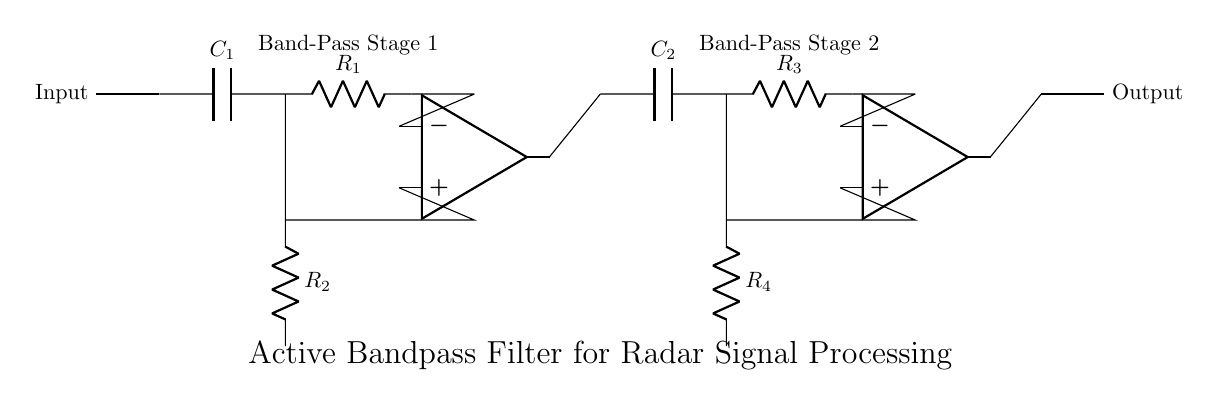What are the two main types of components used in this active bandpass filter? The circuit contains capacitors and resistors. Capacitance is represented by C_1 and C_2, while resistance is depicted by R_1, R_2, R_3, and R_4.
Answer: capacitors and resistors What is the purpose of the operational amplifiers in this circuit? The operational amplifiers (op amps) serve to amplify the signals after they pass through the filtering stages, providing the necessary gain for effective radar signal processing.
Answer: amplify signals How many stages does this active bandpass filter consist of? The diagram shows two band-pass stages, each including its own set of components for filtering.
Answer: two stages What is the configuration of the first stage of this active bandpass filter? The first stage consists of a capacitor (C_1) in series with a resistor (R_1) and a parallel combination of resistor (R_2) to ground. This configuration allows for filtering of specific frequency ranges.
Answer: series and parallel configuration What happens to the input signal as it passes through the filter? The input signal is attenuated for frequencies outside the passband determined by the configuration of the capacitors and resistors. Only desired frequencies will be amplified and sent to the output.
Answer: attenuated and amplified Which component determines the cutoff frequency of the filter? The cutoff frequency is determined by the values of the capacitors and the resistors in the circuit. Specifically, the combinations of R_1, R_2 with C_1 for the first stage and R_3, R_4 with C_2 for the second stage dictate this frequency.
Answer: capacitors and resistors 